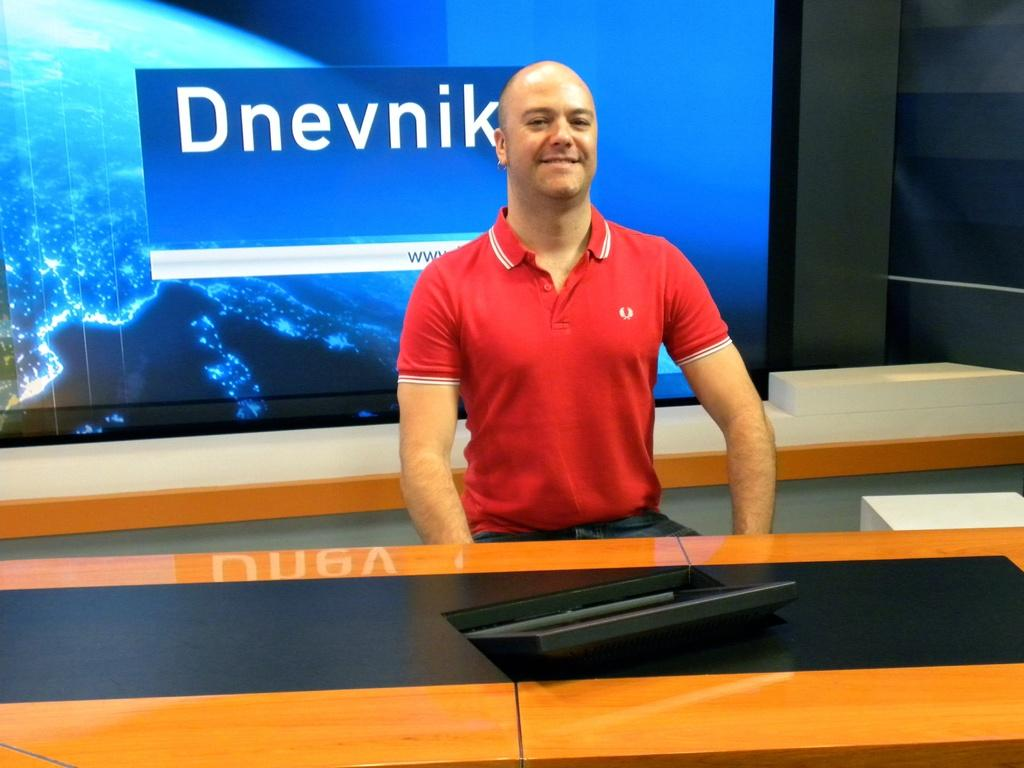<image>
Summarize the visual content of the image. A man in red Fred Perry polo top stands in front of a screen with the word Dnevnik on it. 